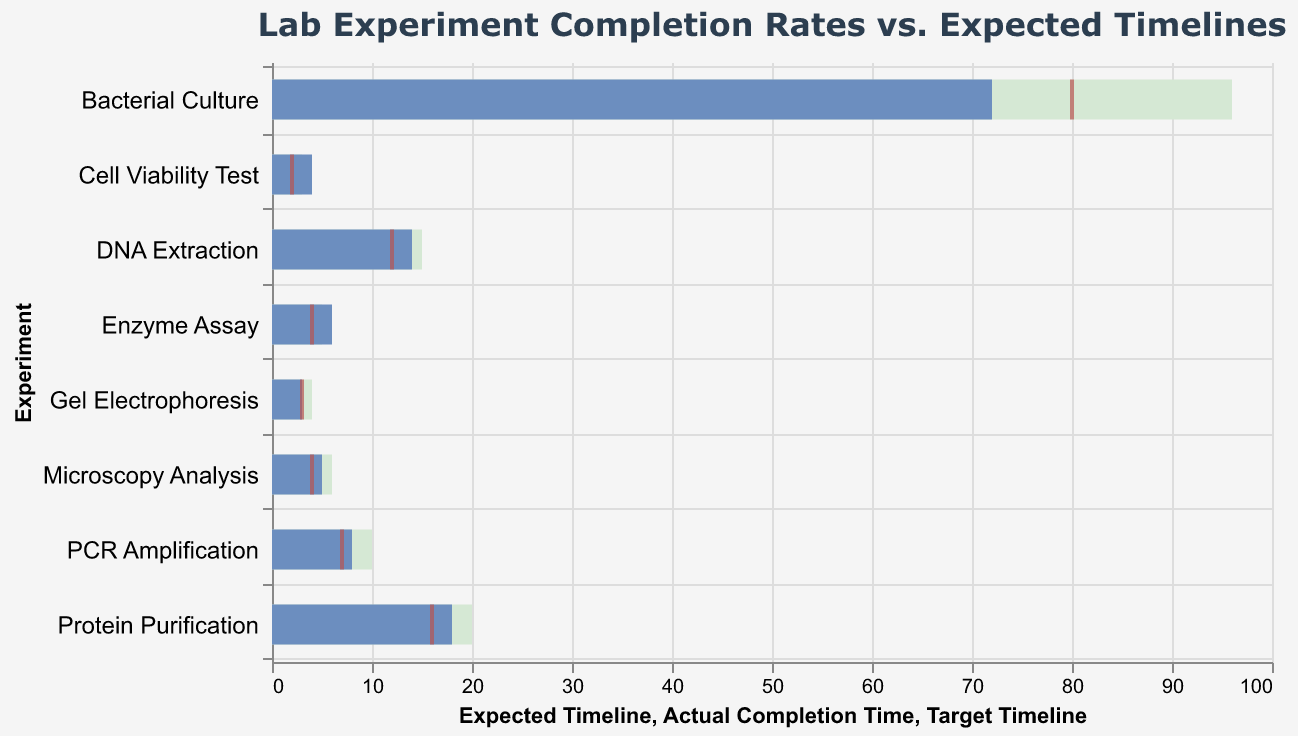what is the title of the plot? The title is located at the top of the chart and reads "Lab Experiment Completion Rates vs. Expected Timelines".
Answer: Lab Experiment Completion Rates vs. Expected Timelines Which experiment took the longest time to complete? By comparing the 'Actual Completion Time' bars for each experiment, the longest bar corresponds to "Bacterial Culture" with a completion time of 72 hours.
Answer: Bacterial Culture Which experiment met its target timeline exactly? By locating the ticks that align exactly with the bars for 'Actual Completion Time', you can see that "Gel Electrophoresis" meets the target and actual timelines at 3 hours.
Answer: Gel Electrophoresis How much longer did Protein Purification take compared to its target timeline? Subtract the 'Target Timeline' value from the 'Actual Completion Time' value for Protein Purification: 18 (Actual) - 16 (Target) = 2 hours.
Answer: 2 hours For which experiments was the actual completion time greater than the expected timeline? Compare the 'Actual Completion Time' bars to the 'Expected Timeline' bars for each experiment, and both "Enzyme Assay" and "Cell Viability Test" took longer than expected timelines.
Answer: Enzyme Assay, Cell Viability Test Compared to the actual completion time, which experiment has the largest difference from its target timeline? Calculate the differences for each experiment and compare. Bacterial Culture has the largest difference: 72 (Actual) - 80 (Target) = -8, but in absolute terms, it is 8 hours.
Answer: Bacterial Culture How many experiments were completed faster than their expected timelines? Identify experiments where the 'Actual Completion Time' bar is shorter than the 'Expected Timeline' bar. These are "PCR Amplification", "Gel Electrophoresis", "Protein Purification", and "Microscopy Analysis".
Answer: 4 What is the average actual completion time for all the experiments? Sum up all 'Actual Completion Time' values and divide by the number of experiments: (14+8+3+72+6+5+18+4)/8 = 130/8 = 16.25 hours.
Answer: 16.25 hours Which experiment had the shortest expected timeline? By looking at the shortest 'Expected Timeline' bar, "Cell Viability Test" has the shortest expected timeline of 3 hours.
Answer: Cell Viability Test 